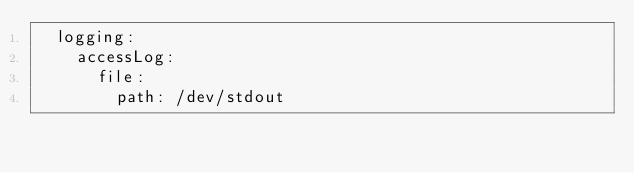Convert code to text. <code><loc_0><loc_0><loc_500><loc_500><_YAML_>  logging:
    accessLog:
      file:
        path: /dev/stdout
</code> 